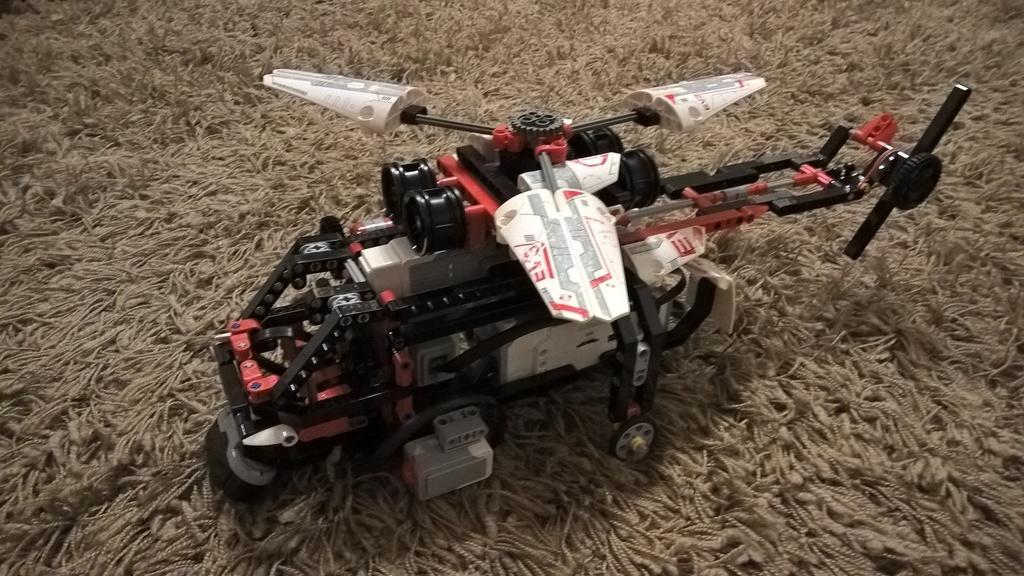Can you describe this image briefly? In the image there is a toy helicopter on a woolen mat. 